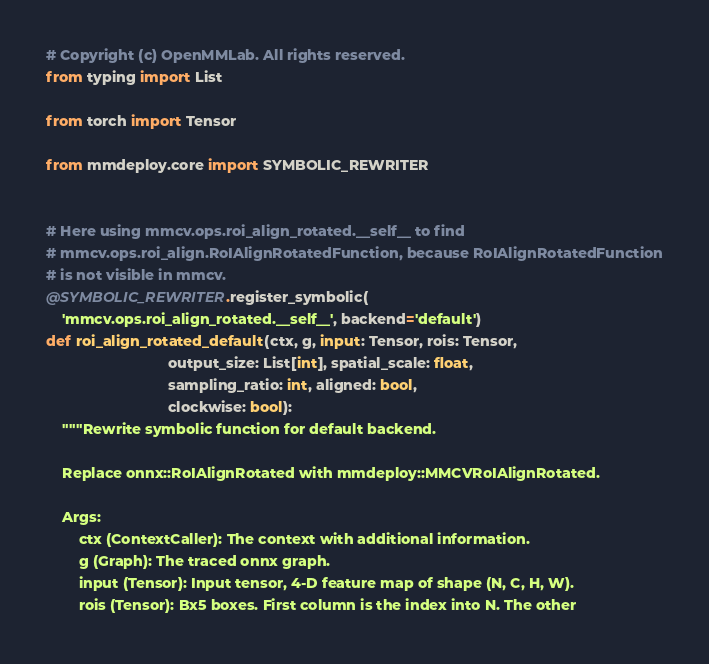<code> <loc_0><loc_0><loc_500><loc_500><_Python_># Copyright (c) OpenMMLab. All rights reserved.
from typing import List

from torch import Tensor

from mmdeploy.core import SYMBOLIC_REWRITER


# Here using mmcv.ops.roi_align_rotated.__self__ to find
# mmcv.ops.roi_align.RoIAlignRotatedFunction, because RoIAlignRotatedFunction
# is not visible in mmcv.
@SYMBOLIC_REWRITER.register_symbolic(
    'mmcv.ops.roi_align_rotated.__self__', backend='default')
def roi_align_rotated_default(ctx, g, input: Tensor, rois: Tensor,
                              output_size: List[int], spatial_scale: float,
                              sampling_ratio: int, aligned: bool,
                              clockwise: bool):
    """Rewrite symbolic function for default backend.

    Replace onnx::RoIAlignRotated with mmdeploy::MMCVRoIAlignRotated.

    Args:
        ctx (ContextCaller): The context with additional information.
        g (Graph): The traced onnx graph.
        input (Tensor): Input tensor, 4-D feature map of shape (N, C, H, W).
        rois (Tensor): Bx5 boxes. First column is the index into N. The other</code> 